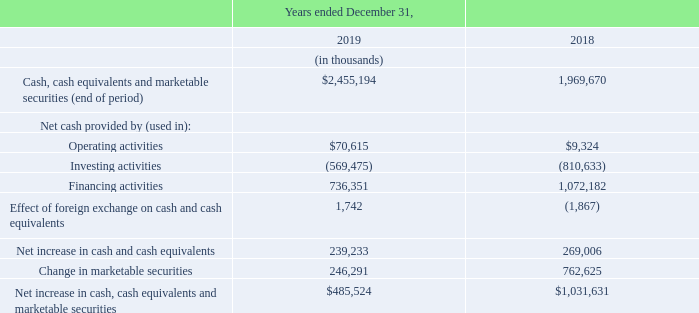Cash, Cash Equivalents and Marketable Securities
Cash, cash equivalents, and marketable securities increased by $485.5 million to $2,455.2 million as at December 31, 2019 from $ 1,969.7 million as at December 31, 2018, primarily as a result of proceeds from the public offering in September 2019, cash provided by our operating activities, and proceeds from the exercise of stock options.
Cash equivalents and marketable securities include money market funds, repurchase agreements, term deposits, U.S. and Canadian federal bonds, corporate bonds, and commercial paper, all maturing within the 12 months from December 31, 2019.
The following table summarizes our total cash, cash equivalents and marketable securities as at December 31, 2019 and 2018 as well as our operating, investing and financing activities for the years ended December 31, 2019 and 2018:
Cash Flows From Operating Activities
Our largest source of operating cash is from subscription solutions. These payments are typically paid to us at the beginning of the applicable subscription period, except for our Shopify Plus merchants who typically pay us at the end of their monthly billing cycle. We also generate significant cash flows from our Shopify Payments processing fee arrangements, which are received on a daily basis as transactions are processed. Our primary uses of cash from operating activities are for third-party payment processing fees, employee-related expenditures, advancing funds to merchants through Shopify Capital, marketing programs, third-party shipping and fulfillment partners, outsourced hosting costs, and leased facilities.
For the year ended December 31, 2019, cash provided by operating activities was $70.6 million. This was primarily as a result of our net loss of $124.8 million, which once adjusted for $158.5 million of stock-based compensation expense, $35.7 million of amortization and depreciation, a $37.9 million increase in deferred income taxes, a $15.9 million increase of our provision for uncollectible merchant cash advances and loans, and an unrealized foreign exchange loss of $3.2 million, contributed $50.4 million of positive cash flows. Additional cash of $162.9 million resulted from the following increases in operating liabilities: $84.6 million in accounts payable and accrued liabilities due to indirect taxes payable, payroll liabilities, and payment processing and interchange fees; $64.6 million in income tax assets and liabilities; $12.3 million in deferred revenue due to the growth in sales of our subscription solutions along with the acquisition of 6RS; and $1.5 million increase in net lease liabilities. These were offset by $142.8 million of cash used resulting from the following increases in operating assets: $74.2 million in merchant cash advances and loans as we continued to grow Shopify Capital; $56.2 million in trade and other receivables; and $12.4 million in other current assets driven primarily by an increase in prepaid expenses, forward contract assets designated for hedge accounting, and deposits.
For the year ended December 31, 2018, cash provided by operating activities was $9.3 million. This was primarily as a result of our net loss of $64.6 million, which once adjusted for $95.7 million of stock-based compensation expense, $27.1 million of amortization and depreciation, a $5.9 million increase of our provision for uncollectible merchant cash advances, and an unrealized foreign exchange loss of $1.3 million, contributed $65.4 million of positive cash flows. Additional cash of $38.1 million resulted from the following increases in operating liabilities: $20.6 million in accounts payable and accrued liabilities; $9.0 million in deferred revenue; and $8.4 million in lease liabilities. These were offset by $94.2 million of cash used resulting from the following increases in operating assets: $50.7 million in merchant cash advances and loans; $32.6 million in trade and other receivables; and $10.8 million in other current assets.
Cash Flows From Investing Activities
Cash flows used in investing activities are primarily related to the purchase and sale of marketable securities, business acquisitions, purchases of leasehold improvements and furniture and fixtures to support our expanding infrastructure and workforce, purchases of computer equipment, and software development costs eligible for capitalization.
Net cash used in investing activities in the year ended December 31, 2019 was $ 569.5 million, which was driven by $265.5 million used to make business acquisitions, most of which was for the 6RS acquisition on October 17, 2019, net purchases of $241.6 million in marketable securities, $ 56.8 million used to purchase property and equipment, which primarily consisted of expenditures on leasehold improvements, and $5.6 million used for purchasing and developing software to add functionality to our platform and support our expanding merchant base.
Net cash used in investing activities in the year ended December 31, 2018 was $810.6 million, reflecting net purchases of $749.7 million in marketable securities. Cash used in investing activities also included $28.0 million used to purchase property and equipment, which primarily consisted of expenditures on leasehold improvements, $19.4 million used to make business acquisitions, and $13.6 million used for purchasing and developing software.
Cash Flows From Financing Activities
To date, cash flows from financing activities have related to proceeds from private placements, public offerings, and exercises of stock options.
Net cash provided by financing activities in the year ended December 31, 2019 was $736.4 million driven mainly by the $688.0 million raised by our September 2019 public offering, and $48.3 million in proceeds from the issuance of Class A subordinate voting shares and Class B multiple voting shares as a result of stock option exercises. This compares to $1,072.2 million for the same period in 2018 of which $1,041.7 million was raised by our February and December 2018 public offerings while the remaining $30.5 million related to stock option exercises.
What is Shopify's largest source of operating cash from? Subscription solutions. What is Shopify's primary uses of cash from its operating activities? Third-party payment processing fees, employee-related expenditures, advancing funds to merchants through shopify capital, marketing programs, third-party shipping and fulfillment partners, outsourced hosting costs, and leased facilities. How much is the cash provided by operating activities for year ended December 31, 2019?
Answer scale should be: thousand. $70,615. What is the average net cash provided by operating activities for 2018 and 2019?
Answer scale should be: thousand. ($70,615+$9,324)/2
Answer: 39969.5. What is the average net cash provided by financing activities for 2018 and 2019?
Answer scale should be: thousand. (736,351+1,072,182)/2
Answer: 904266.5. What is the change in net increase in cash and cash equivalents for year ended 2018 and 2019 ?
Answer scale should be: thousand. 239,233-269,006
Answer: -29773. 